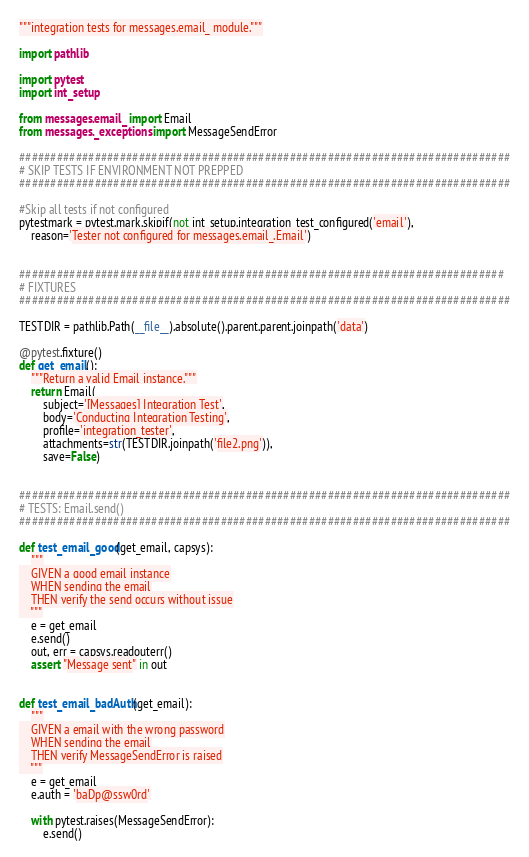Convert code to text. <code><loc_0><loc_0><loc_500><loc_500><_Python_>"""integration tests for messages.email_ module."""

import pathlib

import pytest
import int_setup

from messages.email_ import Email
from messages._exceptions import MessageSendError

##############################################################################
# SKIP TESTS IF ENVIRONMENT NOT PREPPED
##############################################################################

#Skip all tests if not configured
pytestmark = pytest.mark.skipif(not int_setup.integration_test_configured('email'),
    reason='Tester not configured for messages.email_.Email')


#############################################################################
# FIXTURES
##############################################################################

TESTDIR = pathlib.Path(__file__).absolute().parent.parent.joinpath('data')

@pytest.fixture()
def get_email():
    """Return a valid Email instance."""
    return Email(
        subject='[Messages] Integration Test',
        body='Conducting Integration Testing',
        profile='integration_tester',
        attachments=str(TESTDIR.joinpath('file2.png')),
        save=False)


##############################################################################
# TESTS: Email.send()
##############################################################################

def test_email_good(get_email, capsys):
    """
    GIVEN a good email instance
    WHEN sending the email
    THEN verify the send occurs without issue
    """
    e = get_email
    e.send()
    out, err = capsys.readouterr()
    assert "Message sent" in out


def test_email_badAuth(get_email):
    """
    GIVEN a email with the wrong password
    WHEN sending the email
    THEN verify MessageSendError is raised
    """
    e = get_email
    e.auth = 'baDp@ssw0rd'

    with pytest.raises(MessageSendError):
        e.send()
</code> 